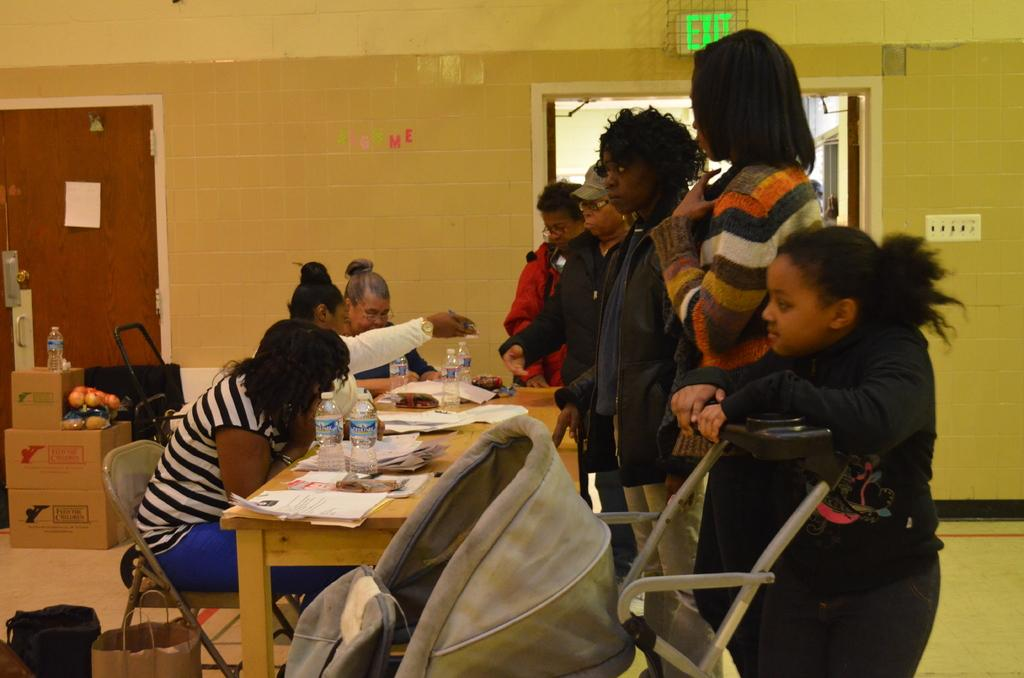What are the people in the image doing? There are people sitting and standing in the image. What can be seen in the background of the image? There is a wall, a door, a window, and a switch in the background of the image. What is placed on the floor in the image? There are boxes placed on the floor in the image. What type of snow can be seen falling outside the window in the image? There is no snow visible in the image, and the window does not show any outdoor scene. 